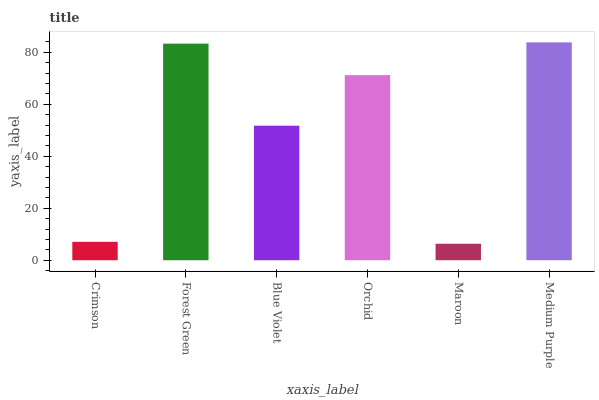Is Forest Green the minimum?
Answer yes or no. No. Is Forest Green the maximum?
Answer yes or no. No. Is Forest Green greater than Crimson?
Answer yes or no. Yes. Is Crimson less than Forest Green?
Answer yes or no. Yes. Is Crimson greater than Forest Green?
Answer yes or no. No. Is Forest Green less than Crimson?
Answer yes or no. No. Is Orchid the high median?
Answer yes or no. Yes. Is Blue Violet the low median?
Answer yes or no. Yes. Is Crimson the high median?
Answer yes or no. No. Is Medium Purple the low median?
Answer yes or no. No. 